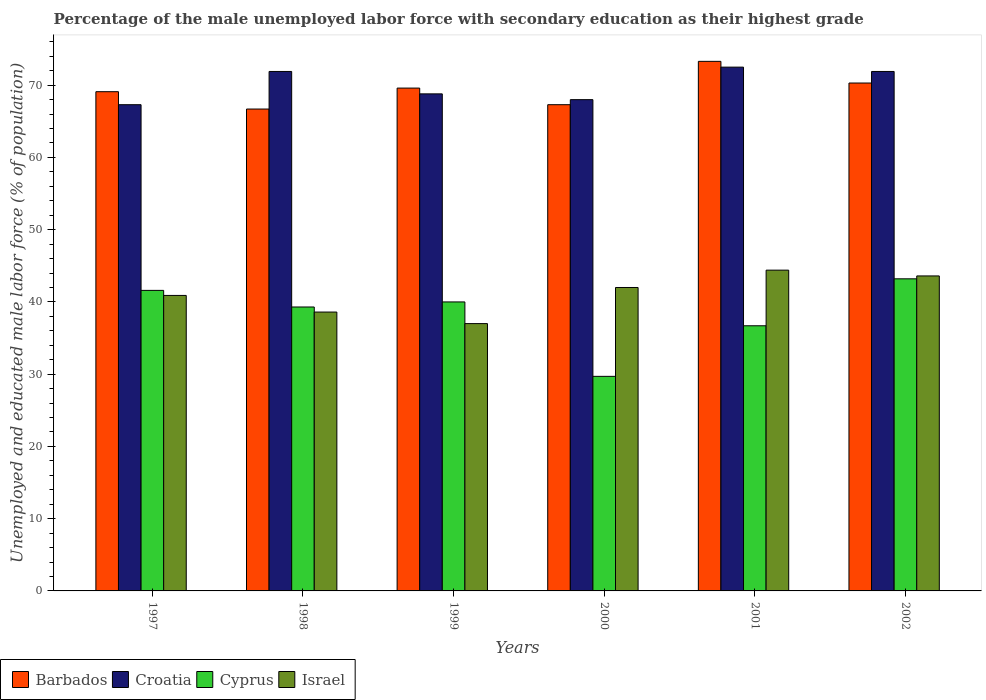Are the number of bars per tick equal to the number of legend labels?
Provide a succinct answer. Yes. How many bars are there on the 5th tick from the left?
Make the answer very short. 4. What is the percentage of the unemployed male labor force with secondary education in Barbados in 2002?
Ensure brevity in your answer.  70.3. Across all years, what is the maximum percentage of the unemployed male labor force with secondary education in Barbados?
Ensure brevity in your answer.  73.3. Across all years, what is the minimum percentage of the unemployed male labor force with secondary education in Cyprus?
Offer a terse response. 29.7. In which year was the percentage of the unemployed male labor force with secondary education in Barbados maximum?
Provide a short and direct response. 2001. In which year was the percentage of the unemployed male labor force with secondary education in Croatia minimum?
Offer a terse response. 1997. What is the total percentage of the unemployed male labor force with secondary education in Barbados in the graph?
Offer a very short reply. 416.3. What is the difference between the percentage of the unemployed male labor force with secondary education in Israel in 1998 and that in 2001?
Your answer should be very brief. -5.8. What is the difference between the percentage of the unemployed male labor force with secondary education in Israel in 2000 and the percentage of the unemployed male labor force with secondary education in Cyprus in 1997?
Ensure brevity in your answer.  0.4. What is the average percentage of the unemployed male labor force with secondary education in Croatia per year?
Provide a succinct answer. 70.07. In the year 2001, what is the difference between the percentage of the unemployed male labor force with secondary education in Israel and percentage of the unemployed male labor force with secondary education in Barbados?
Make the answer very short. -28.9. What is the ratio of the percentage of the unemployed male labor force with secondary education in Israel in 2000 to that in 2001?
Keep it short and to the point. 0.95. Is the percentage of the unemployed male labor force with secondary education in Croatia in 1998 less than that in 2001?
Give a very brief answer. Yes. What is the difference between the highest and the second highest percentage of the unemployed male labor force with secondary education in Cyprus?
Provide a succinct answer. 1.6. What is the difference between the highest and the lowest percentage of the unemployed male labor force with secondary education in Croatia?
Provide a succinct answer. 5.2. Is it the case that in every year, the sum of the percentage of the unemployed male labor force with secondary education in Barbados and percentage of the unemployed male labor force with secondary education in Israel is greater than the sum of percentage of the unemployed male labor force with secondary education in Croatia and percentage of the unemployed male labor force with secondary education in Cyprus?
Give a very brief answer. No. What does the 3rd bar from the left in 1997 represents?
Provide a short and direct response. Cyprus. What does the 2nd bar from the right in 1999 represents?
Your response must be concise. Cyprus. Is it the case that in every year, the sum of the percentage of the unemployed male labor force with secondary education in Croatia and percentage of the unemployed male labor force with secondary education in Cyprus is greater than the percentage of the unemployed male labor force with secondary education in Barbados?
Provide a short and direct response. Yes. How many bars are there?
Your response must be concise. 24. Are all the bars in the graph horizontal?
Provide a short and direct response. No. How many years are there in the graph?
Your response must be concise. 6. What is the difference between two consecutive major ticks on the Y-axis?
Your answer should be very brief. 10. How many legend labels are there?
Offer a terse response. 4. What is the title of the graph?
Offer a very short reply. Percentage of the male unemployed labor force with secondary education as their highest grade. What is the label or title of the Y-axis?
Ensure brevity in your answer.  Unemployed and educated male labor force (% of population). What is the Unemployed and educated male labor force (% of population) in Barbados in 1997?
Give a very brief answer. 69.1. What is the Unemployed and educated male labor force (% of population) in Croatia in 1997?
Provide a short and direct response. 67.3. What is the Unemployed and educated male labor force (% of population) in Cyprus in 1997?
Your answer should be very brief. 41.6. What is the Unemployed and educated male labor force (% of population) in Israel in 1997?
Keep it short and to the point. 40.9. What is the Unemployed and educated male labor force (% of population) in Barbados in 1998?
Your response must be concise. 66.7. What is the Unemployed and educated male labor force (% of population) of Croatia in 1998?
Offer a terse response. 71.9. What is the Unemployed and educated male labor force (% of population) in Cyprus in 1998?
Offer a very short reply. 39.3. What is the Unemployed and educated male labor force (% of population) of Israel in 1998?
Offer a terse response. 38.6. What is the Unemployed and educated male labor force (% of population) of Barbados in 1999?
Make the answer very short. 69.6. What is the Unemployed and educated male labor force (% of population) of Croatia in 1999?
Your answer should be very brief. 68.8. What is the Unemployed and educated male labor force (% of population) in Barbados in 2000?
Ensure brevity in your answer.  67.3. What is the Unemployed and educated male labor force (% of population) in Cyprus in 2000?
Your response must be concise. 29.7. What is the Unemployed and educated male labor force (% of population) in Barbados in 2001?
Your answer should be very brief. 73.3. What is the Unemployed and educated male labor force (% of population) of Croatia in 2001?
Ensure brevity in your answer.  72.5. What is the Unemployed and educated male labor force (% of population) in Cyprus in 2001?
Provide a succinct answer. 36.7. What is the Unemployed and educated male labor force (% of population) in Israel in 2001?
Your answer should be very brief. 44.4. What is the Unemployed and educated male labor force (% of population) in Barbados in 2002?
Offer a terse response. 70.3. What is the Unemployed and educated male labor force (% of population) of Croatia in 2002?
Provide a succinct answer. 71.9. What is the Unemployed and educated male labor force (% of population) of Cyprus in 2002?
Provide a short and direct response. 43.2. What is the Unemployed and educated male labor force (% of population) of Israel in 2002?
Offer a very short reply. 43.6. Across all years, what is the maximum Unemployed and educated male labor force (% of population) of Barbados?
Provide a succinct answer. 73.3. Across all years, what is the maximum Unemployed and educated male labor force (% of population) in Croatia?
Keep it short and to the point. 72.5. Across all years, what is the maximum Unemployed and educated male labor force (% of population) of Cyprus?
Offer a terse response. 43.2. Across all years, what is the maximum Unemployed and educated male labor force (% of population) of Israel?
Offer a very short reply. 44.4. Across all years, what is the minimum Unemployed and educated male labor force (% of population) of Barbados?
Offer a very short reply. 66.7. Across all years, what is the minimum Unemployed and educated male labor force (% of population) of Croatia?
Your answer should be compact. 67.3. Across all years, what is the minimum Unemployed and educated male labor force (% of population) of Cyprus?
Offer a very short reply. 29.7. What is the total Unemployed and educated male labor force (% of population) in Barbados in the graph?
Offer a very short reply. 416.3. What is the total Unemployed and educated male labor force (% of population) in Croatia in the graph?
Provide a succinct answer. 420.4. What is the total Unemployed and educated male labor force (% of population) of Cyprus in the graph?
Offer a terse response. 230.5. What is the total Unemployed and educated male labor force (% of population) in Israel in the graph?
Offer a terse response. 246.5. What is the difference between the Unemployed and educated male labor force (% of population) in Barbados in 1997 and that in 1998?
Keep it short and to the point. 2.4. What is the difference between the Unemployed and educated male labor force (% of population) in Croatia in 1997 and that in 1998?
Offer a very short reply. -4.6. What is the difference between the Unemployed and educated male labor force (% of population) of Cyprus in 1997 and that in 1998?
Ensure brevity in your answer.  2.3. What is the difference between the Unemployed and educated male labor force (% of population) in Israel in 1997 and that in 1998?
Give a very brief answer. 2.3. What is the difference between the Unemployed and educated male labor force (% of population) of Israel in 1997 and that in 1999?
Ensure brevity in your answer.  3.9. What is the difference between the Unemployed and educated male labor force (% of population) of Israel in 1997 and that in 2000?
Provide a short and direct response. -1.1. What is the difference between the Unemployed and educated male labor force (% of population) in Croatia in 1997 and that in 2001?
Make the answer very short. -5.2. What is the difference between the Unemployed and educated male labor force (% of population) in Cyprus in 1997 and that in 2001?
Ensure brevity in your answer.  4.9. What is the difference between the Unemployed and educated male labor force (% of population) of Israel in 1997 and that in 2001?
Give a very brief answer. -3.5. What is the difference between the Unemployed and educated male labor force (% of population) of Barbados in 1997 and that in 2002?
Provide a succinct answer. -1.2. What is the difference between the Unemployed and educated male labor force (% of population) of Croatia in 1997 and that in 2002?
Your response must be concise. -4.6. What is the difference between the Unemployed and educated male labor force (% of population) in Cyprus in 1997 and that in 2002?
Keep it short and to the point. -1.6. What is the difference between the Unemployed and educated male labor force (% of population) of Barbados in 1998 and that in 1999?
Offer a very short reply. -2.9. What is the difference between the Unemployed and educated male labor force (% of population) of Croatia in 1998 and that in 1999?
Give a very brief answer. 3.1. What is the difference between the Unemployed and educated male labor force (% of population) of Cyprus in 1998 and that in 1999?
Make the answer very short. -0.7. What is the difference between the Unemployed and educated male labor force (% of population) of Israel in 1998 and that in 2000?
Offer a terse response. -3.4. What is the difference between the Unemployed and educated male labor force (% of population) in Croatia in 1998 and that in 2001?
Your response must be concise. -0.6. What is the difference between the Unemployed and educated male labor force (% of population) in Barbados in 1998 and that in 2002?
Your answer should be compact. -3.6. What is the difference between the Unemployed and educated male labor force (% of population) in Israel in 1998 and that in 2002?
Give a very brief answer. -5. What is the difference between the Unemployed and educated male labor force (% of population) in Israel in 1999 and that in 2002?
Make the answer very short. -6.6. What is the difference between the Unemployed and educated male labor force (% of population) in Croatia in 2000 and that in 2001?
Your answer should be very brief. -4.5. What is the difference between the Unemployed and educated male labor force (% of population) of Israel in 2000 and that in 2001?
Your answer should be compact. -2.4. What is the difference between the Unemployed and educated male labor force (% of population) in Croatia in 2000 and that in 2002?
Provide a succinct answer. -3.9. What is the difference between the Unemployed and educated male labor force (% of population) in Cyprus in 2000 and that in 2002?
Offer a terse response. -13.5. What is the difference between the Unemployed and educated male labor force (% of population) of Barbados in 2001 and that in 2002?
Your response must be concise. 3. What is the difference between the Unemployed and educated male labor force (% of population) of Cyprus in 2001 and that in 2002?
Your answer should be very brief. -6.5. What is the difference between the Unemployed and educated male labor force (% of population) of Israel in 2001 and that in 2002?
Offer a terse response. 0.8. What is the difference between the Unemployed and educated male labor force (% of population) of Barbados in 1997 and the Unemployed and educated male labor force (% of population) of Croatia in 1998?
Provide a succinct answer. -2.8. What is the difference between the Unemployed and educated male labor force (% of population) of Barbados in 1997 and the Unemployed and educated male labor force (% of population) of Cyprus in 1998?
Keep it short and to the point. 29.8. What is the difference between the Unemployed and educated male labor force (% of population) in Barbados in 1997 and the Unemployed and educated male labor force (% of population) in Israel in 1998?
Provide a succinct answer. 30.5. What is the difference between the Unemployed and educated male labor force (% of population) of Croatia in 1997 and the Unemployed and educated male labor force (% of population) of Cyprus in 1998?
Your response must be concise. 28. What is the difference between the Unemployed and educated male labor force (% of population) of Croatia in 1997 and the Unemployed and educated male labor force (% of population) of Israel in 1998?
Keep it short and to the point. 28.7. What is the difference between the Unemployed and educated male labor force (% of population) in Barbados in 1997 and the Unemployed and educated male labor force (% of population) in Croatia in 1999?
Your response must be concise. 0.3. What is the difference between the Unemployed and educated male labor force (% of population) in Barbados in 1997 and the Unemployed and educated male labor force (% of population) in Cyprus in 1999?
Your response must be concise. 29.1. What is the difference between the Unemployed and educated male labor force (% of population) of Barbados in 1997 and the Unemployed and educated male labor force (% of population) of Israel in 1999?
Offer a terse response. 32.1. What is the difference between the Unemployed and educated male labor force (% of population) in Croatia in 1997 and the Unemployed and educated male labor force (% of population) in Cyprus in 1999?
Make the answer very short. 27.3. What is the difference between the Unemployed and educated male labor force (% of population) in Croatia in 1997 and the Unemployed and educated male labor force (% of population) in Israel in 1999?
Offer a very short reply. 30.3. What is the difference between the Unemployed and educated male labor force (% of population) in Cyprus in 1997 and the Unemployed and educated male labor force (% of population) in Israel in 1999?
Your response must be concise. 4.6. What is the difference between the Unemployed and educated male labor force (% of population) in Barbados in 1997 and the Unemployed and educated male labor force (% of population) in Cyprus in 2000?
Provide a succinct answer. 39.4. What is the difference between the Unemployed and educated male labor force (% of population) in Barbados in 1997 and the Unemployed and educated male labor force (% of population) in Israel in 2000?
Keep it short and to the point. 27.1. What is the difference between the Unemployed and educated male labor force (% of population) of Croatia in 1997 and the Unemployed and educated male labor force (% of population) of Cyprus in 2000?
Ensure brevity in your answer.  37.6. What is the difference between the Unemployed and educated male labor force (% of population) of Croatia in 1997 and the Unemployed and educated male labor force (% of population) of Israel in 2000?
Your response must be concise. 25.3. What is the difference between the Unemployed and educated male labor force (% of population) in Barbados in 1997 and the Unemployed and educated male labor force (% of population) in Croatia in 2001?
Ensure brevity in your answer.  -3.4. What is the difference between the Unemployed and educated male labor force (% of population) of Barbados in 1997 and the Unemployed and educated male labor force (% of population) of Cyprus in 2001?
Your answer should be compact. 32.4. What is the difference between the Unemployed and educated male labor force (% of population) in Barbados in 1997 and the Unemployed and educated male labor force (% of population) in Israel in 2001?
Provide a short and direct response. 24.7. What is the difference between the Unemployed and educated male labor force (% of population) of Croatia in 1997 and the Unemployed and educated male labor force (% of population) of Cyprus in 2001?
Provide a succinct answer. 30.6. What is the difference between the Unemployed and educated male labor force (% of population) in Croatia in 1997 and the Unemployed and educated male labor force (% of population) in Israel in 2001?
Offer a very short reply. 22.9. What is the difference between the Unemployed and educated male labor force (% of population) of Barbados in 1997 and the Unemployed and educated male labor force (% of population) of Cyprus in 2002?
Give a very brief answer. 25.9. What is the difference between the Unemployed and educated male labor force (% of population) in Barbados in 1997 and the Unemployed and educated male labor force (% of population) in Israel in 2002?
Provide a short and direct response. 25.5. What is the difference between the Unemployed and educated male labor force (% of population) of Croatia in 1997 and the Unemployed and educated male labor force (% of population) of Cyprus in 2002?
Keep it short and to the point. 24.1. What is the difference between the Unemployed and educated male labor force (% of population) of Croatia in 1997 and the Unemployed and educated male labor force (% of population) of Israel in 2002?
Keep it short and to the point. 23.7. What is the difference between the Unemployed and educated male labor force (% of population) in Cyprus in 1997 and the Unemployed and educated male labor force (% of population) in Israel in 2002?
Your response must be concise. -2. What is the difference between the Unemployed and educated male labor force (% of population) of Barbados in 1998 and the Unemployed and educated male labor force (% of population) of Croatia in 1999?
Your answer should be very brief. -2.1. What is the difference between the Unemployed and educated male labor force (% of population) in Barbados in 1998 and the Unemployed and educated male labor force (% of population) in Cyprus in 1999?
Keep it short and to the point. 26.7. What is the difference between the Unemployed and educated male labor force (% of population) of Barbados in 1998 and the Unemployed and educated male labor force (% of population) of Israel in 1999?
Offer a very short reply. 29.7. What is the difference between the Unemployed and educated male labor force (% of population) of Croatia in 1998 and the Unemployed and educated male labor force (% of population) of Cyprus in 1999?
Offer a very short reply. 31.9. What is the difference between the Unemployed and educated male labor force (% of population) in Croatia in 1998 and the Unemployed and educated male labor force (% of population) in Israel in 1999?
Ensure brevity in your answer.  34.9. What is the difference between the Unemployed and educated male labor force (% of population) in Cyprus in 1998 and the Unemployed and educated male labor force (% of population) in Israel in 1999?
Offer a very short reply. 2.3. What is the difference between the Unemployed and educated male labor force (% of population) in Barbados in 1998 and the Unemployed and educated male labor force (% of population) in Croatia in 2000?
Give a very brief answer. -1.3. What is the difference between the Unemployed and educated male labor force (% of population) of Barbados in 1998 and the Unemployed and educated male labor force (% of population) of Cyprus in 2000?
Keep it short and to the point. 37. What is the difference between the Unemployed and educated male labor force (% of population) of Barbados in 1998 and the Unemployed and educated male labor force (% of population) of Israel in 2000?
Ensure brevity in your answer.  24.7. What is the difference between the Unemployed and educated male labor force (% of population) in Croatia in 1998 and the Unemployed and educated male labor force (% of population) in Cyprus in 2000?
Give a very brief answer. 42.2. What is the difference between the Unemployed and educated male labor force (% of population) of Croatia in 1998 and the Unemployed and educated male labor force (% of population) of Israel in 2000?
Keep it short and to the point. 29.9. What is the difference between the Unemployed and educated male labor force (% of population) of Cyprus in 1998 and the Unemployed and educated male labor force (% of population) of Israel in 2000?
Provide a short and direct response. -2.7. What is the difference between the Unemployed and educated male labor force (% of population) in Barbados in 1998 and the Unemployed and educated male labor force (% of population) in Israel in 2001?
Give a very brief answer. 22.3. What is the difference between the Unemployed and educated male labor force (% of population) of Croatia in 1998 and the Unemployed and educated male labor force (% of population) of Cyprus in 2001?
Your response must be concise. 35.2. What is the difference between the Unemployed and educated male labor force (% of population) of Cyprus in 1998 and the Unemployed and educated male labor force (% of population) of Israel in 2001?
Give a very brief answer. -5.1. What is the difference between the Unemployed and educated male labor force (% of population) of Barbados in 1998 and the Unemployed and educated male labor force (% of population) of Croatia in 2002?
Make the answer very short. -5.2. What is the difference between the Unemployed and educated male labor force (% of population) in Barbados in 1998 and the Unemployed and educated male labor force (% of population) in Israel in 2002?
Your answer should be compact. 23.1. What is the difference between the Unemployed and educated male labor force (% of population) in Croatia in 1998 and the Unemployed and educated male labor force (% of population) in Cyprus in 2002?
Provide a short and direct response. 28.7. What is the difference between the Unemployed and educated male labor force (% of population) in Croatia in 1998 and the Unemployed and educated male labor force (% of population) in Israel in 2002?
Keep it short and to the point. 28.3. What is the difference between the Unemployed and educated male labor force (% of population) in Barbados in 1999 and the Unemployed and educated male labor force (% of population) in Croatia in 2000?
Give a very brief answer. 1.6. What is the difference between the Unemployed and educated male labor force (% of population) of Barbados in 1999 and the Unemployed and educated male labor force (% of population) of Cyprus in 2000?
Provide a succinct answer. 39.9. What is the difference between the Unemployed and educated male labor force (% of population) of Barbados in 1999 and the Unemployed and educated male labor force (% of population) of Israel in 2000?
Offer a terse response. 27.6. What is the difference between the Unemployed and educated male labor force (% of population) of Croatia in 1999 and the Unemployed and educated male labor force (% of population) of Cyprus in 2000?
Keep it short and to the point. 39.1. What is the difference between the Unemployed and educated male labor force (% of population) in Croatia in 1999 and the Unemployed and educated male labor force (% of population) in Israel in 2000?
Provide a short and direct response. 26.8. What is the difference between the Unemployed and educated male labor force (% of population) of Barbados in 1999 and the Unemployed and educated male labor force (% of population) of Croatia in 2001?
Your response must be concise. -2.9. What is the difference between the Unemployed and educated male labor force (% of population) of Barbados in 1999 and the Unemployed and educated male labor force (% of population) of Cyprus in 2001?
Provide a short and direct response. 32.9. What is the difference between the Unemployed and educated male labor force (% of population) of Barbados in 1999 and the Unemployed and educated male labor force (% of population) of Israel in 2001?
Your response must be concise. 25.2. What is the difference between the Unemployed and educated male labor force (% of population) in Croatia in 1999 and the Unemployed and educated male labor force (% of population) in Cyprus in 2001?
Provide a short and direct response. 32.1. What is the difference between the Unemployed and educated male labor force (% of population) of Croatia in 1999 and the Unemployed and educated male labor force (% of population) of Israel in 2001?
Provide a short and direct response. 24.4. What is the difference between the Unemployed and educated male labor force (% of population) of Barbados in 1999 and the Unemployed and educated male labor force (% of population) of Cyprus in 2002?
Provide a short and direct response. 26.4. What is the difference between the Unemployed and educated male labor force (% of population) in Barbados in 1999 and the Unemployed and educated male labor force (% of population) in Israel in 2002?
Your answer should be very brief. 26. What is the difference between the Unemployed and educated male labor force (% of population) of Croatia in 1999 and the Unemployed and educated male labor force (% of population) of Cyprus in 2002?
Offer a terse response. 25.6. What is the difference between the Unemployed and educated male labor force (% of population) in Croatia in 1999 and the Unemployed and educated male labor force (% of population) in Israel in 2002?
Provide a succinct answer. 25.2. What is the difference between the Unemployed and educated male labor force (% of population) in Barbados in 2000 and the Unemployed and educated male labor force (% of population) in Cyprus in 2001?
Your answer should be very brief. 30.6. What is the difference between the Unemployed and educated male labor force (% of population) in Barbados in 2000 and the Unemployed and educated male labor force (% of population) in Israel in 2001?
Provide a succinct answer. 22.9. What is the difference between the Unemployed and educated male labor force (% of population) in Croatia in 2000 and the Unemployed and educated male labor force (% of population) in Cyprus in 2001?
Make the answer very short. 31.3. What is the difference between the Unemployed and educated male labor force (% of population) of Croatia in 2000 and the Unemployed and educated male labor force (% of population) of Israel in 2001?
Your answer should be very brief. 23.6. What is the difference between the Unemployed and educated male labor force (% of population) in Cyprus in 2000 and the Unemployed and educated male labor force (% of population) in Israel in 2001?
Offer a terse response. -14.7. What is the difference between the Unemployed and educated male labor force (% of population) of Barbados in 2000 and the Unemployed and educated male labor force (% of population) of Cyprus in 2002?
Offer a terse response. 24.1. What is the difference between the Unemployed and educated male labor force (% of population) of Barbados in 2000 and the Unemployed and educated male labor force (% of population) of Israel in 2002?
Your answer should be compact. 23.7. What is the difference between the Unemployed and educated male labor force (% of population) in Croatia in 2000 and the Unemployed and educated male labor force (% of population) in Cyprus in 2002?
Offer a terse response. 24.8. What is the difference between the Unemployed and educated male labor force (% of population) of Croatia in 2000 and the Unemployed and educated male labor force (% of population) of Israel in 2002?
Offer a very short reply. 24.4. What is the difference between the Unemployed and educated male labor force (% of population) in Barbados in 2001 and the Unemployed and educated male labor force (% of population) in Croatia in 2002?
Provide a short and direct response. 1.4. What is the difference between the Unemployed and educated male labor force (% of population) of Barbados in 2001 and the Unemployed and educated male labor force (% of population) of Cyprus in 2002?
Make the answer very short. 30.1. What is the difference between the Unemployed and educated male labor force (% of population) of Barbados in 2001 and the Unemployed and educated male labor force (% of population) of Israel in 2002?
Your answer should be very brief. 29.7. What is the difference between the Unemployed and educated male labor force (% of population) in Croatia in 2001 and the Unemployed and educated male labor force (% of population) in Cyprus in 2002?
Ensure brevity in your answer.  29.3. What is the difference between the Unemployed and educated male labor force (% of population) of Croatia in 2001 and the Unemployed and educated male labor force (% of population) of Israel in 2002?
Your answer should be very brief. 28.9. What is the average Unemployed and educated male labor force (% of population) in Barbados per year?
Give a very brief answer. 69.38. What is the average Unemployed and educated male labor force (% of population) of Croatia per year?
Ensure brevity in your answer.  70.07. What is the average Unemployed and educated male labor force (% of population) in Cyprus per year?
Offer a very short reply. 38.42. What is the average Unemployed and educated male labor force (% of population) of Israel per year?
Your answer should be compact. 41.08. In the year 1997, what is the difference between the Unemployed and educated male labor force (% of population) of Barbados and Unemployed and educated male labor force (% of population) of Israel?
Offer a very short reply. 28.2. In the year 1997, what is the difference between the Unemployed and educated male labor force (% of population) of Croatia and Unemployed and educated male labor force (% of population) of Cyprus?
Provide a succinct answer. 25.7. In the year 1997, what is the difference between the Unemployed and educated male labor force (% of population) in Croatia and Unemployed and educated male labor force (% of population) in Israel?
Your response must be concise. 26.4. In the year 1998, what is the difference between the Unemployed and educated male labor force (% of population) of Barbados and Unemployed and educated male labor force (% of population) of Cyprus?
Keep it short and to the point. 27.4. In the year 1998, what is the difference between the Unemployed and educated male labor force (% of population) of Barbados and Unemployed and educated male labor force (% of population) of Israel?
Keep it short and to the point. 28.1. In the year 1998, what is the difference between the Unemployed and educated male labor force (% of population) in Croatia and Unemployed and educated male labor force (% of population) in Cyprus?
Give a very brief answer. 32.6. In the year 1998, what is the difference between the Unemployed and educated male labor force (% of population) of Croatia and Unemployed and educated male labor force (% of population) of Israel?
Provide a succinct answer. 33.3. In the year 1999, what is the difference between the Unemployed and educated male labor force (% of population) of Barbados and Unemployed and educated male labor force (% of population) of Cyprus?
Your answer should be very brief. 29.6. In the year 1999, what is the difference between the Unemployed and educated male labor force (% of population) of Barbados and Unemployed and educated male labor force (% of population) of Israel?
Provide a succinct answer. 32.6. In the year 1999, what is the difference between the Unemployed and educated male labor force (% of population) of Croatia and Unemployed and educated male labor force (% of population) of Cyprus?
Give a very brief answer. 28.8. In the year 1999, what is the difference between the Unemployed and educated male labor force (% of population) of Croatia and Unemployed and educated male labor force (% of population) of Israel?
Ensure brevity in your answer.  31.8. In the year 2000, what is the difference between the Unemployed and educated male labor force (% of population) of Barbados and Unemployed and educated male labor force (% of population) of Cyprus?
Offer a terse response. 37.6. In the year 2000, what is the difference between the Unemployed and educated male labor force (% of population) of Barbados and Unemployed and educated male labor force (% of population) of Israel?
Give a very brief answer. 25.3. In the year 2000, what is the difference between the Unemployed and educated male labor force (% of population) in Croatia and Unemployed and educated male labor force (% of population) in Cyprus?
Offer a terse response. 38.3. In the year 2000, what is the difference between the Unemployed and educated male labor force (% of population) of Croatia and Unemployed and educated male labor force (% of population) of Israel?
Your answer should be very brief. 26. In the year 2000, what is the difference between the Unemployed and educated male labor force (% of population) of Cyprus and Unemployed and educated male labor force (% of population) of Israel?
Give a very brief answer. -12.3. In the year 2001, what is the difference between the Unemployed and educated male labor force (% of population) of Barbados and Unemployed and educated male labor force (% of population) of Cyprus?
Your answer should be very brief. 36.6. In the year 2001, what is the difference between the Unemployed and educated male labor force (% of population) of Barbados and Unemployed and educated male labor force (% of population) of Israel?
Make the answer very short. 28.9. In the year 2001, what is the difference between the Unemployed and educated male labor force (% of population) in Croatia and Unemployed and educated male labor force (% of population) in Cyprus?
Make the answer very short. 35.8. In the year 2001, what is the difference between the Unemployed and educated male labor force (% of population) in Croatia and Unemployed and educated male labor force (% of population) in Israel?
Provide a short and direct response. 28.1. In the year 2001, what is the difference between the Unemployed and educated male labor force (% of population) of Cyprus and Unemployed and educated male labor force (% of population) of Israel?
Offer a terse response. -7.7. In the year 2002, what is the difference between the Unemployed and educated male labor force (% of population) in Barbados and Unemployed and educated male labor force (% of population) in Croatia?
Make the answer very short. -1.6. In the year 2002, what is the difference between the Unemployed and educated male labor force (% of population) in Barbados and Unemployed and educated male labor force (% of population) in Cyprus?
Provide a succinct answer. 27.1. In the year 2002, what is the difference between the Unemployed and educated male labor force (% of population) of Barbados and Unemployed and educated male labor force (% of population) of Israel?
Offer a terse response. 26.7. In the year 2002, what is the difference between the Unemployed and educated male labor force (% of population) of Croatia and Unemployed and educated male labor force (% of population) of Cyprus?
Your response must be concise. 28.7. In the year 2002, what is the difference between the Unemployed and educated male labor force (% of population) of Croatia and Unemployed and educated male labor force (% of population) of Israel?
Ensure brevity in your answer.  28.3. What is the ratio of the Unemployed and educated male labor force (% of population) of Barbados in 1997 to that in 1998?
Offer a very short reply. 1.04. What is the ratio of the Unemployed and educated male labor force (% of population) of Croatia in 1997 to that in 1998?
Ensure brevity in your answer.  0.94. What is the ratio of the Unemployed and educated male labor force (% of population) of Cyprus in 1997 to that in 1998?
Provide a short and direct response. 1.06. What is the ratio of the Unemployed and educated male labor force (% of population) of Israel in 1997 to that in 1998?
Keep it short and to the point. 1.06. What is the ratio of the Unemployed and educated male labor force (% of population) of Barbados in 1997 to that in 1999?
Offer a very short reply. 0.99. What is the ratio of the Unemployed and educated male labor force (% of population) in Croatia in 1997 to that in 1999?
Ensure brevity in your answer.  0.98. What is the ratio of the Unemployed and educated male labor force (% of population) of Israel in 1997 to that in 1999?
Your response must be concise. 1.11. What is the ratio of the Unemployed and educated male labor force (% of population) of Barbados in 1997 to that in 2000?
Provide a short and direct response. 1.03. What is the ratio of the Unemployed and educated male labor force (% of population) of Cyprus in 1997 to that in 2000?
Provide a short and direct response. 1.4. What is the ratio of the Unemployed and educated male labor force (% of population) in Israel in 1997 to that in 2000?
Make the answer very short. 0.97. What is the ratio of the Unemployed and educated male labor force (% of population) in Barbados in 1997 to that in 2001?
Provide a short and direct response. 0.94. What is the ratio of the Unemployed and educated male labor force (% of population) in Croatia in 1997 to that in 2001?
Keep it short and to the point. 0.93. What is the ratio of the Unemployed and educated male labor force (% of population) of Cyprus in 1997 to that in 2001?
Provide a short and direct response. 1.13. What is the ratio of the Unemployed and educated male labor force (% of population) of Israel in 1997 to that in 2001?
Offer a terse response. 0.92. What is the ratio of the Unemployed and educated male labor force (% of population) in Barbados in 1997 to that in 2002?
Keep it short and to the point. 0.98. What is the ratio of the Unemployed and educated male labor force (% of population) in Croatia in 1997 to that in 2002?
Your answer should be compact. 0.94. What is the ratio of the Unemployed and educated male labor force (% of population) of Israel in 1997 to that in 2002?
Your response must be concise. 0.94. What is the ratio of the Unemployed and educated male labor force (% of population) in Croatia in 1998 to that in 1999?
Give a very brief answer. 1.05. What is the ratio of the Unemployed and educated male labor force (% of population) in Cyprus in 1998 to that in 1999?
Give a very brief answer. 0.98. What is the ratio of the Unemployed and educated male labor force (% of population) in Israel in 1998 to that in 1999?
Provide a short and direct response. 1.04. What is the ratio of the Unemployed and educated male labor force (% of population) in Croatia in 1998 to that in 2000?
Offer a terse response. 1.06. What is the ratio of the Unemployed and educated male labor force (% of population) of Cyprus in 1998 to that in 2000?
Offer a terse response. 1.32. What is the ratio of the Unemployed and educated male labor force (% of population) of Israel in 1998 to that in 2000?
Provide a short and direct response. 0.92. What is the ratio of the Unemployed and educated male labor force (% of population) of Barbados in 1998 to that in 2001?
Your answer should be very brief. 0.91. What is the ratio of the Unemployed and educated male labor force (% of population) in Cyprus in 1998 to that in 2001?
Make the answer very short. 1.07. What is the ratio of the Unemployed and educated male labor force (% of population) of Israel in 1998 to that in 2001?
Keep it short and to the point. 0.87. What is the ratio of the Unemployed and educated male labor force (% of population) in Barbados in 1998 to that in 2002?
Your answer should be very brief. 0.95. What is the ratio of the Unemployed and educated male labor force (% of population) in Croatia in 1998 to that in 2002?
Offer a terse response. 1. What is the ratio of the Unemployed and educated male labor force (% of population) of Cyprus in 1998 to that in 2002?
Your answer should be compact. 0.91. What is the ratio of the Unemployed and educated male labor force (% of population) of Israel in 1998 to that in 2002?
Your answer should be very brief. 0.89. What is the ratio of the Unemployed and educated male labor force (% of population) of Barbados in 1999 to that in 2000?
Your response must be concise. 1.03. What is the ratio of the Unemployed and educated male labor force (% of population) in Croatia in 1999 to that in 2000?
Make the answer very short. 1.01. What is the ratio of the Unemployed and educated male labor force (% of population) in Cyprus in 1999 to that in 2000?
Give a very brief answer. 1.35. What is the ratio of the Unemployed and educated male labor force (% of population) of Israel in 1999 to that in 2000?
Your answer should be very brief. 0.88. What is the ratio of the Unemployed and educated male labor force (% of population) in Barbados in 1999 to that in 2001?
Ensure brevity in your answer.  0.95. What is the ratio of the Unemployed and educated male labor force (% of population) of Croatia in 1999 to that in 2001?
Ensure brevity in your answer.  0.95. What is the ratio of the Unemployed and educated male labor force (% of population) in Cyprus in 1999 to that in 2001?
Your response must be concise. 1.09. What is the ratio of the Unemployed and educated male labor force (% of population) in Croatia in 1999 to that in 2002?
Provide a short and direct response. 0.96. What is the ratio of the Unemployed and educated male labor force (% of population) in Cyprus in 1999 to that in 2002?
Offer a very short reply. 0.93. What is the ratio of the Unemployed and educated male labor force (% of population) in Israel in 1999 to that in 2002?
Your response must be concise. 0.85. What is the ratio of the Unemployed and educated male labor force (% of population) in Barbados in 2000 to that in 2001?
Offer a very short reply. 0.92. What is the ratio of the Unemployed and educated male labor force (% of population) of Croatia in 2000 to that in 2001?
Your answer should be compact. 0.94. What is the ratio of the Unemployed and educated male labor force (% of population) in Cyprus in 2000 to that in 2001?
Give a very brief answer. 0.81. What is the ratio of the Unemployed and educated male labor force (% of population) of Israel in 2000 to that in 2001?
Ensure brevity in your answer.  0.95. What is the ratio of the Unemployed and educated male labor force (% of population) of Barbados in 2000 to that in 2002?
Your answer should be very brief. 0.96. What is the ratio of the Unemployed and educated male labor force (% of population) in Croatia in 2000 to that in 2002?
Your response must be concise. 0.95. What is the ratio of the Unemployed and educated male labor force (% of population) of Cyprus in 2000 to that in 2002?
Offer a very short reply. 0.69. What is the ratio of the Unemployed and educated male labor force (% of population) in Israel in 2000 to that in 2002?
Make the answer very short. 0.96. What is the ratio of the Unemployed and educated male labor force (% of population) in Barbados in 2001 to that in 2002?
Keep it short and to the point. 1.04. What is the ratio of the Unemployed and educated male labor force (% of population) in Croatia in 2001 to that in 2002?
Give a very brief answer. 1.01. What is the ratio of the Unemployed and educated male labor force (% of population) in Cyprus in 2001 to that in 2002?
Your answer should be very brief. 0.85. What is the ratio of the Unemployed and educated male labor force (% of population) in Israel in 2001 to that in 2002?
Give a very brief answer. 1.02. What is the difference between the highest and the second highest Unemployed and educated male labor force (% of population) in Barbados?
Provide a succinct answer. 3. What is the difference between the highest and the second highest Unemployed and educated male labor force (% of population) in Israel?
Provide a short and direct response. 0.8. What is the difference between the highest and the lowest Unemployed and educated male labor force (% of population) of Cyprus?
Offer a very short reply. 13.5. What is the difference between the highest and the lowest Unemployed and educated male labor force (% of population) of Israel?
Your answer should be very brief. 7.4. 